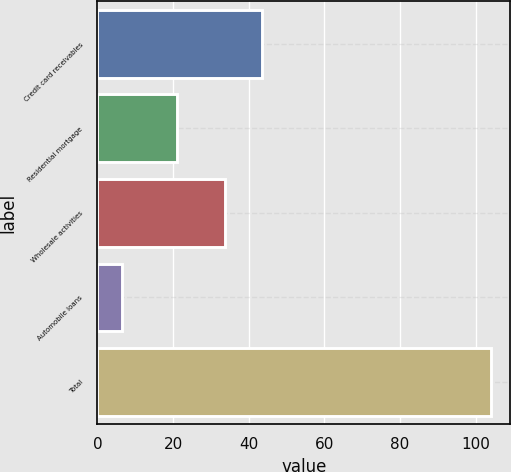<chart> <loc_0><loc_0><loc_500><loc_500><bar_chart><fcel>Credit card receivables<fcel>Residential mortgage<fcel>Wholesale activities<fcel>Automobile loans<fcel>Total<nl><fcel>43.55<fcel>21.1<fcel>33.8<fcel>6.5<fcel>104<nl></chart> 